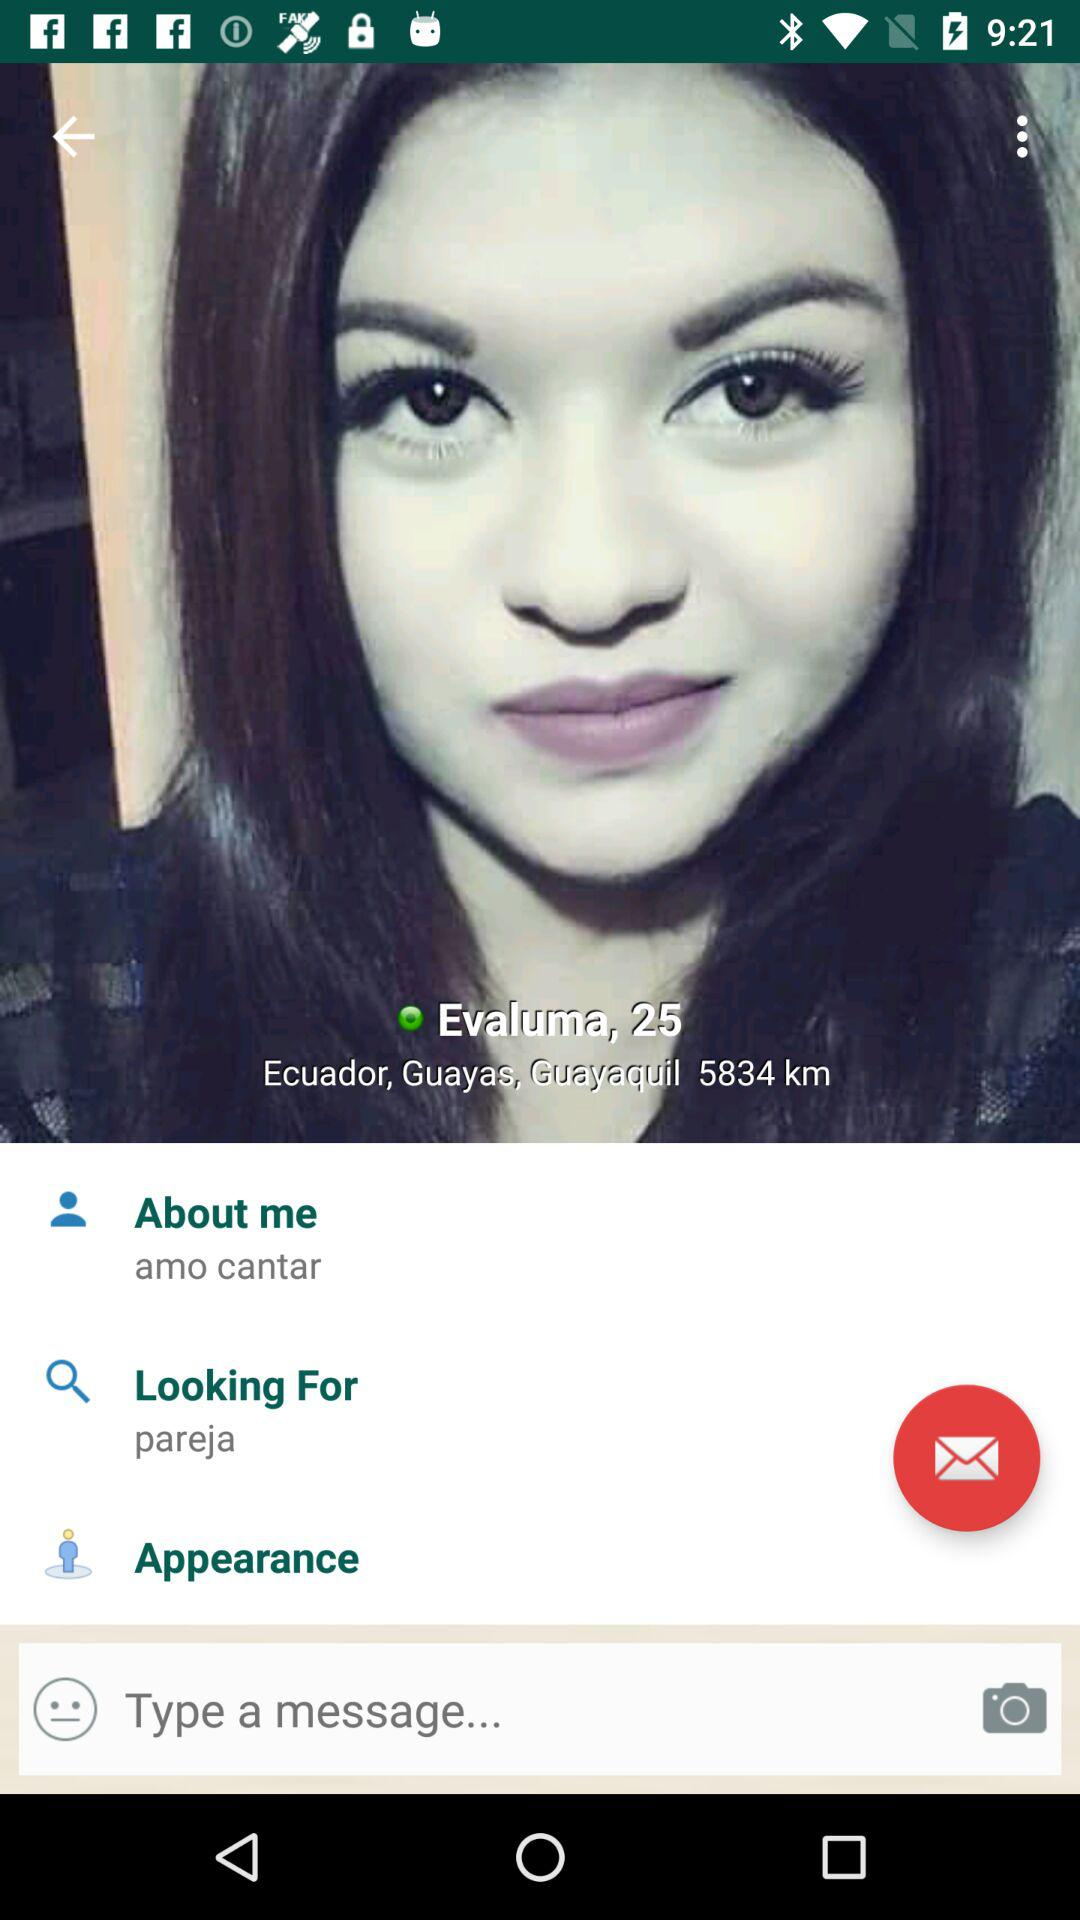What is the age? The age is 25. 